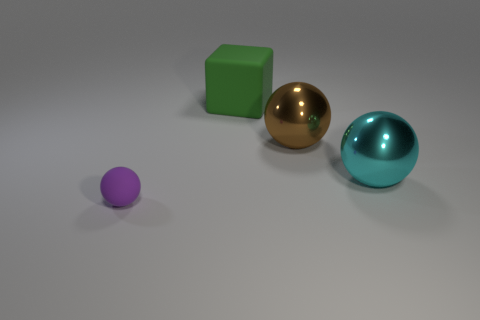What is the material of the big ball right of the big brown ball?
Your answer should be very brief. Metal. Do the thing in front of the cyan shiny object and the brown thing have the same material?
Your answer should be compact. No. What number of things are tiny red metal cylinders or big spheres in front of the brown metallic thing?
Provide a succinct answer. 1. There is a brown thing that is the same shape as the purple rubber object; what is its size?
Provide a short and direct response. Large. Are there any other things that have the same size as the purple matte thing?
Provide a succinct answer. No. There is a small matte ball; are there any objects right of it?
Your answer should be compact. Yes. Are there any purple objects of the same shape as the big brown object?
Offer a terse response. Yes. How many other objects are the same color as the rubber ball?
Offer a very short reply. 0. There is a rubber thing on the left side of the rubber thing that is behind the thing left of the green cube; what is its color?
Provide a short and direct response. Purple. Are there an equal number of things that are behind the purple object and large objects?
Offer a very short reply. Yes. 